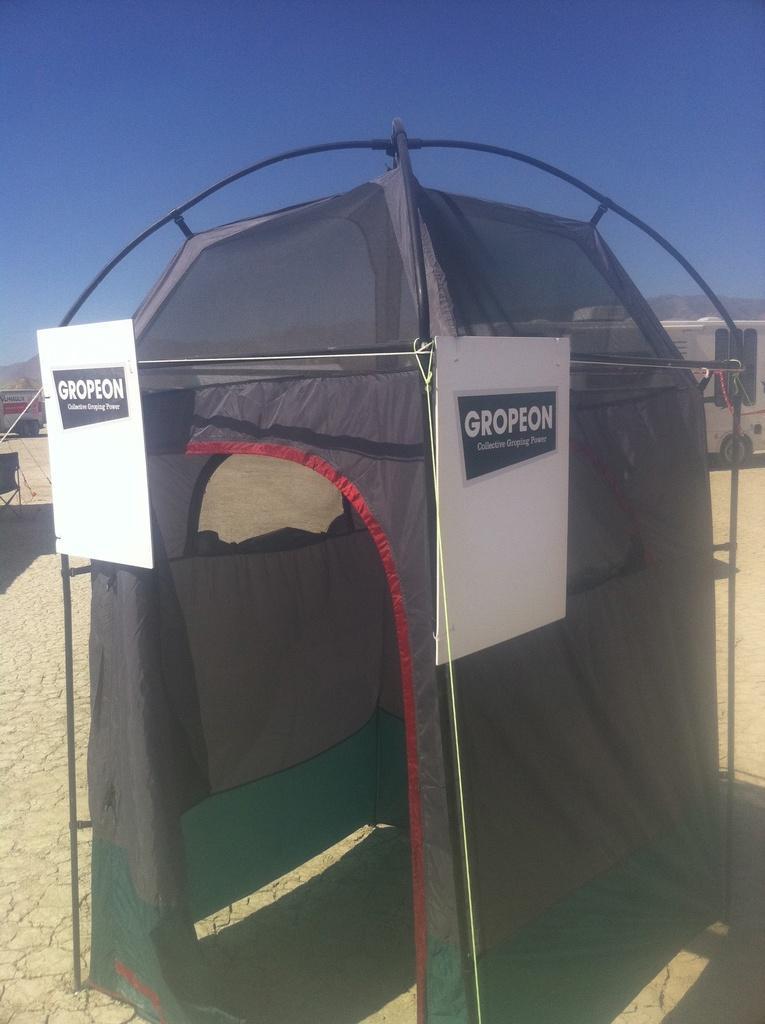Can you describe this image briefly? In this image in the foreground there is one tent, and in the background there are some vehicles and mountains. And there are some boards attached to the tent, on the top of the image there is sky. 